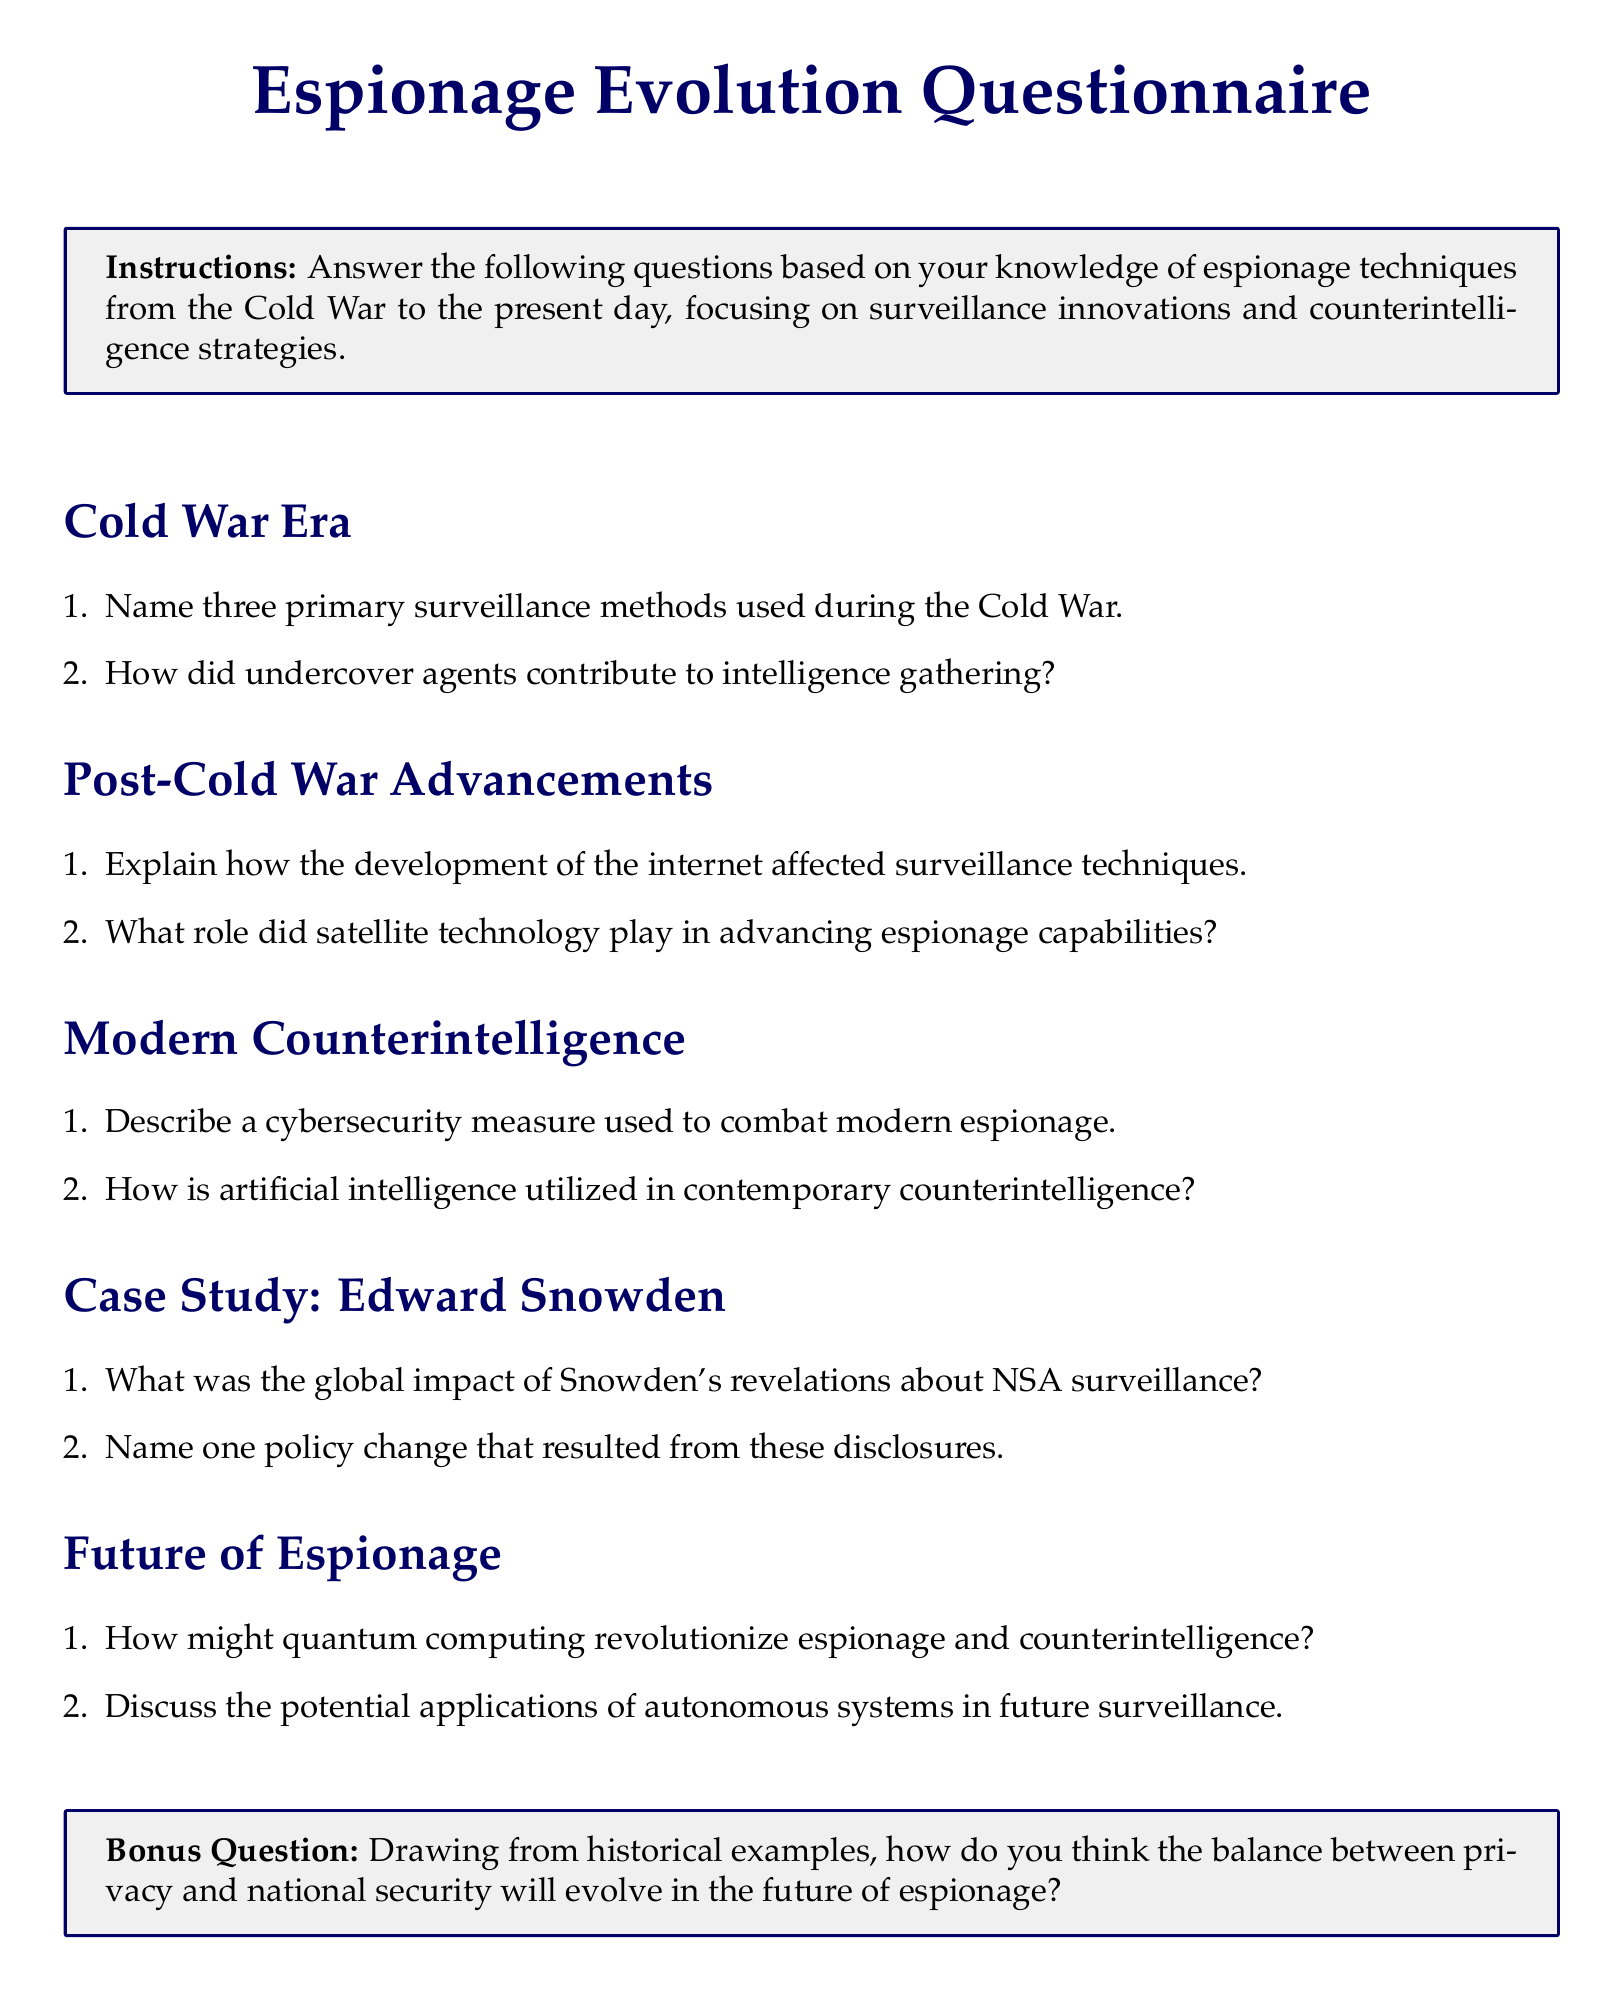What are the two sections in the questionnaire? The sections of the questionnaire are Cold War Era and Post-Cold War Advancements among others.
Answer: Cold War Era, Post-Cold War Advancements What does the questionnaire ask about Edward Snowden? The questionnaire includes questions about the global impact of Snowden's revelations and resulting policy changes.
Answer: Global impact of NSA surveillance, Policy change Name one of the surveillance methods mentioned in the Cold War Era. The question specifically asks for primary surveillance methods used during the Cold War.
Answer: (Any primary method from the answer to the first question) What is the focus of the "Modern Counterintelligence" section? This section is focused on contemporary techniques to combat espionage.
Answer: Contemporary techniques What is the bonus question about? The bonus question relates to the balance between privacy and national security in future espionage.
Answer: Future of espionage How many main sections are in the questionnaire? The document lists several sections, including Cold War Era, Post-Cold War Advancements, Modern Counterintelligence, and others.
Answer: Five 